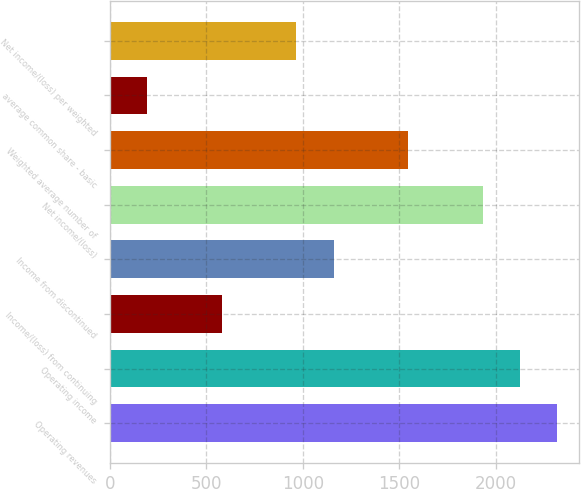<chart> <loc_0><loc_0><loc_500><loc_500><bar_chart><fcel>Operating revenues<fcel>Operating income<fcel>Income/(loss) from continuing<fcel>Income from discontinued<fcel>Net income/(loss)<fcel>Weighted average number of<fcel>average common share - basic<fcel>Net income/(loss) per weighted<nl><fcel>2318.33<fcel>2125.15<fcel>579.71<fcel>1159.25<fcel>1931.97<fcel>1545.61<fcel>193.35<fcel>966.07<nl></chart> 